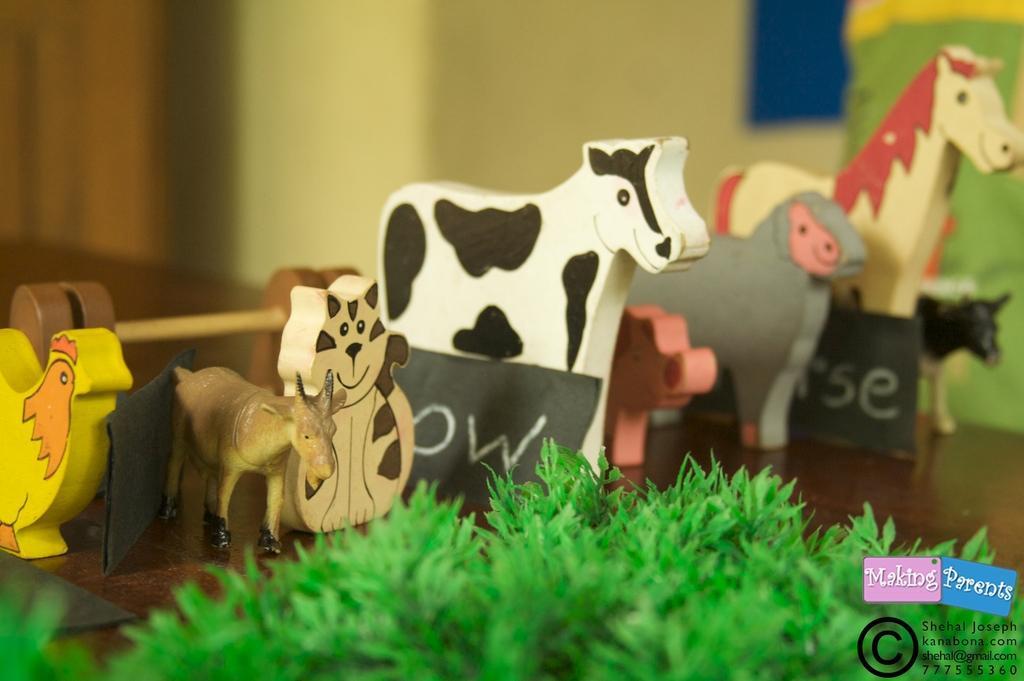Can you describe this image briefly? In this picture we can see toys, name cards, plants and some objects on the ground and we can see a wall in the background, in the bottom right we can see a watermark and some text on it. 